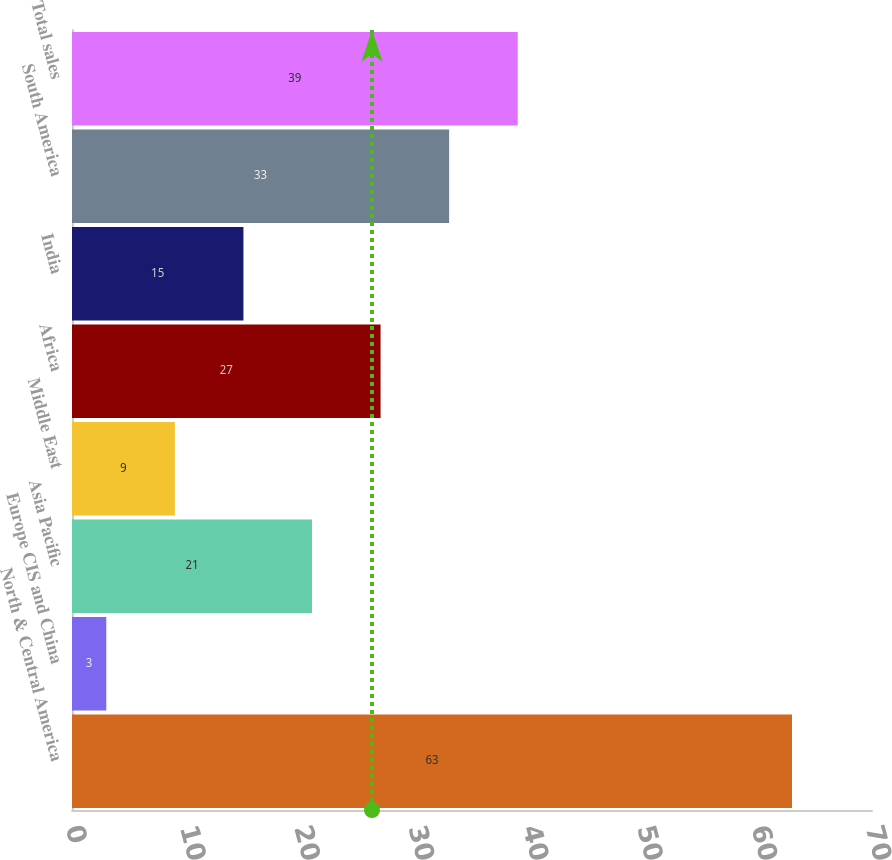Convert chart to OTSL. <chart><loc_0><loc_0><loc_500><loc_500><bar_chart><fcel>North & Central America<fcel>Europe CIS and China<fcel>Asia Pacific<fcel>Middle East<fcel>Africa<fcel>India<fcel>South America<fcel>Total sales<nl><fcel>63<fcel>3<fcel>21<fcel>9<fcel>27<fcel>15<fcel>33<fcel>39<nl></chart> 